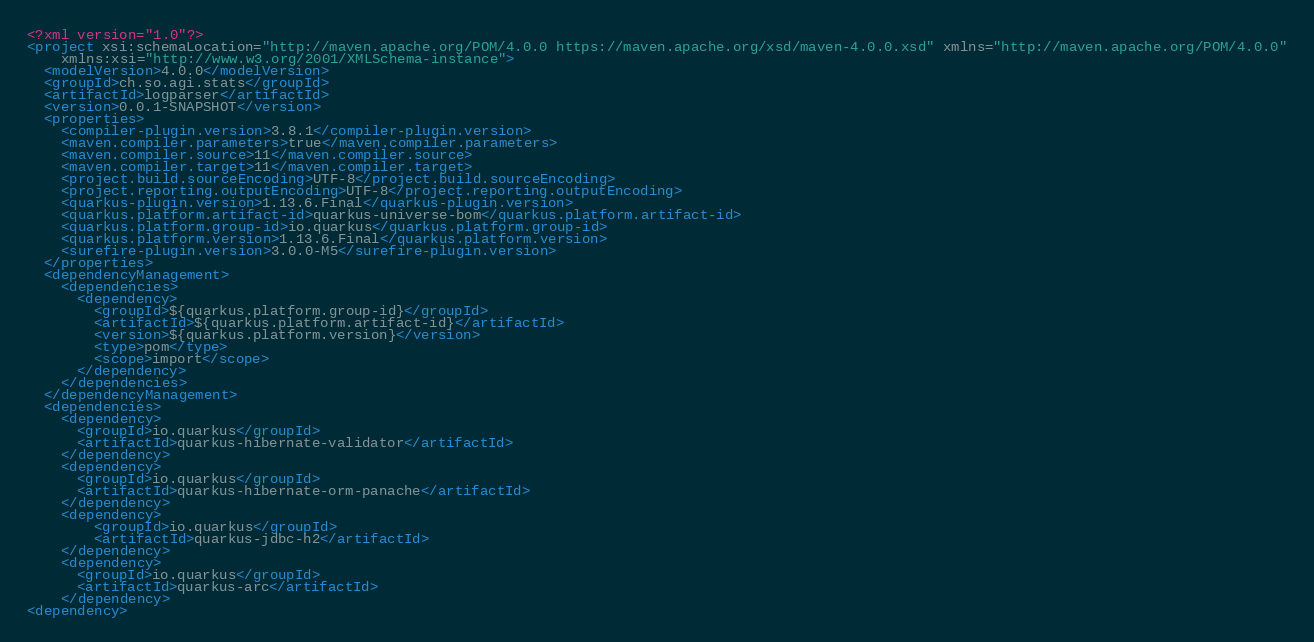<code> <loc_0><loc_0><loc_500><loc_500><_XML_><?xml version="1.0"?>
<project xsi:schemaLocation="http://maven.apache.org/POM/4.0.0 https://maven.apache.org/xsd/maven-4.0.0.xsd" xmlns="http://maven.apache.org/POM/4.0.0"
    xmlns:xsi="http://www.w3.org/2001/XMLSchema-instance">
  <modelVersion>4.0.0</modelVersion>
  <groupId>ch.so.agi.stats</groupId>
  <artifactId>logparser</artifactId>
  <version>0.0.1-SNAPSHOT</version>
  <properties>
    <compiler-plugin.version>3.8.1</compiler-plugin.version>
    <maven.compiler.parameters>true</maven.compiler.parameters>
    <maven.compiler.source>11</maven.compiler.source>
    <maven.compiler.target>11</maven.compiler.target>
    <project.build.sourceEncoding>UTF-8</project.build.sourceEncoding>
    <project.reporting.outputEncoding>UTF-8</project.reporting.outputEncoding>
    <quarkus-plugin.version>1.13.6.Final</quarkus-plugin.version>
    <quarkus.platform.artifact-id>quarkus-universe-bom</quarkus.platform.artifact-id>
    <quarkus.platform.group-id>io.quarkus</quarkus.platform.group-id>
    <quarkus.platform.version>1.13.6.Final</quarkus.platform.version>
    <surefire-plugin.version>3.0.0-M5</surefire-plugin.version>
  </properties>
  <dependencyManagement>
    <dependencies>
      <dependency>
        <groupId>${quarkus.platform.group-id}</groupId>
        <artifactId>${quarkus.platform.artifact-id}</artifactId>
        <version>${quarkus.platform.version}</version>
        <type>pom</type>
        <scope>import</scope>
      </dependency>
    </dependencies>
  </dependencyManagement>
  <dependencies>
    <dependency>
      <groupId>io.quarkus</groupId>
      <artifactId>quarkus-hibernate-validator</artifactId>
    </dependency>
    <dependency>
      <groupId>io.quarkus</groupId>
      <artifactId>quarkus-hibernate-orm-panache</artifactId>
    </dependency>
    <dependency>
        <groupId>io.quarkus</groupId>
        <artifactId>quarkus-jdbc-h2</artifactId>
    </dependency>
    <dependency>
      <groupId>io.quarkus</groupId>
      <artifactId>quarkus-arc</artifactId>
    </dependency>
<dependency></code> 